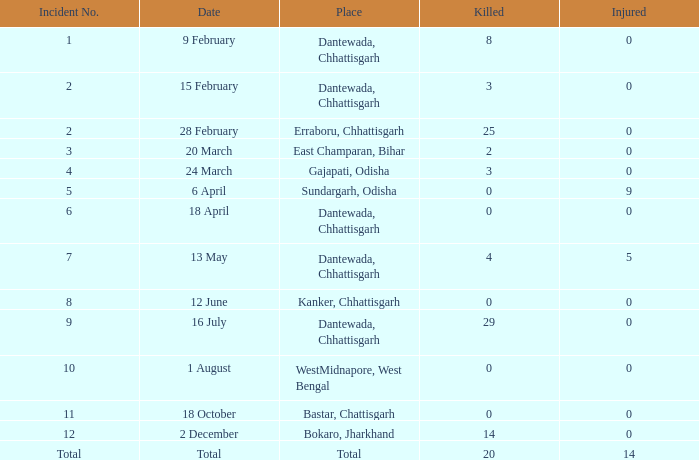What is the least amount of injuries in Dantewada, Chhattisgarh when 8 people were killed? 0.0. 